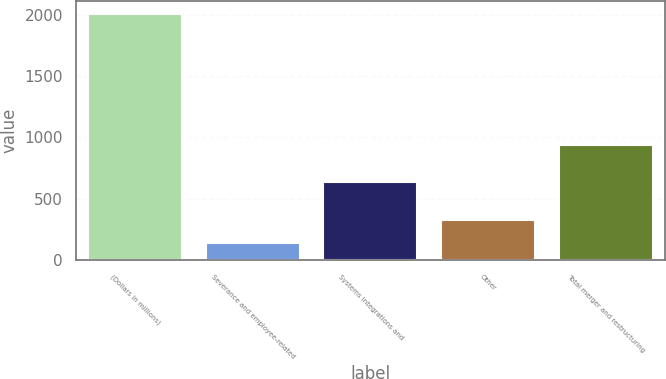<chart> <loc_0><loc_0><loc_500><loc_500><bar_chart><fcel>(Dollars in millions)<fcel>Severance and employee-related<fcel>Systems integrations and<fcel>Other<fcel>Total merger and restructuring<nl><fcel>2008<fcel>138<fcel>640<fcel>325<fcel>935<nl></chart> 